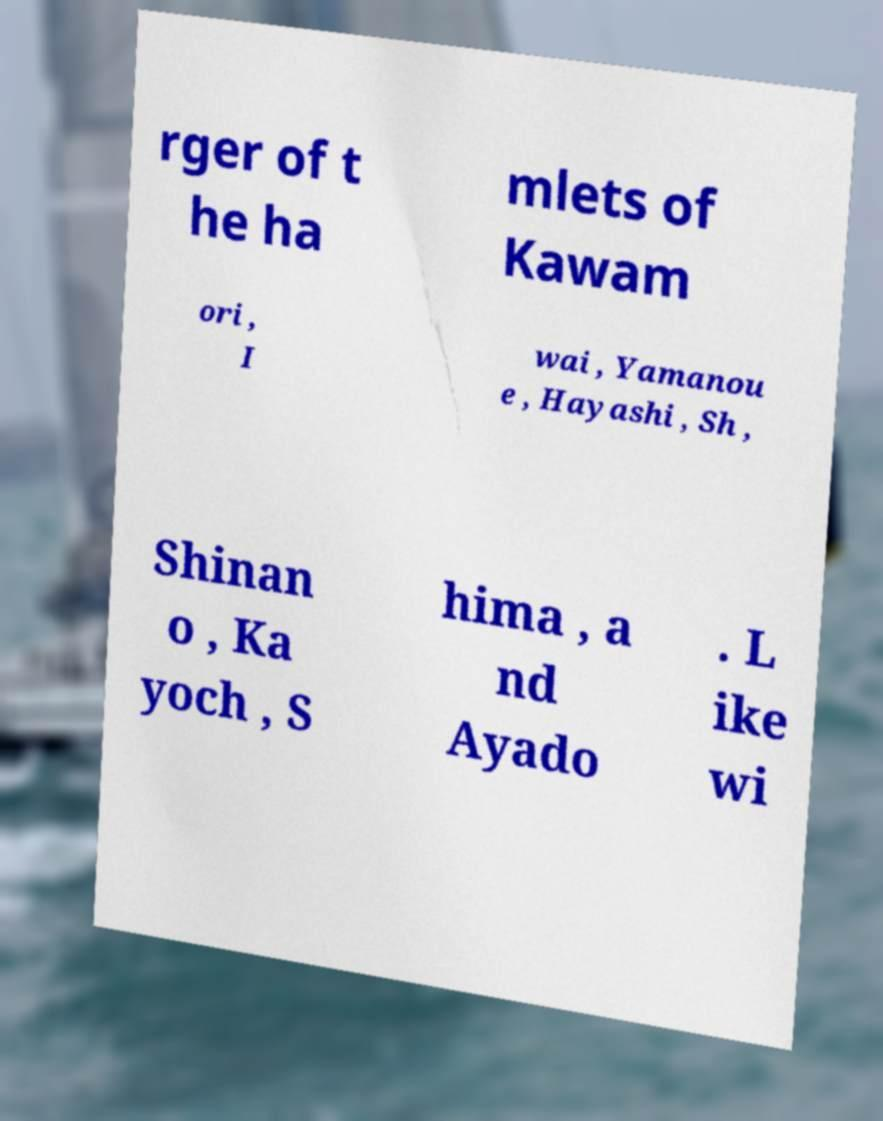Please identify and transcribe the text found in this image. rger of t he ha mlets of Kawam ori , I wai , Yamanou e , Hayashi , Sh , Shinan o , Ka yoch , S hima , a nd Ayado . L ike wi 